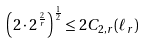<formula> <loc_0><loc_0><loc_500><loc_500>\left ( 2 \cdot 2 ^ { \frac { 2 } { r } } \right ) ^ { \frac { 1 } { 2 } } \leq 2 C _ { 2 , r } ( \ell _ { r } )</formula> 